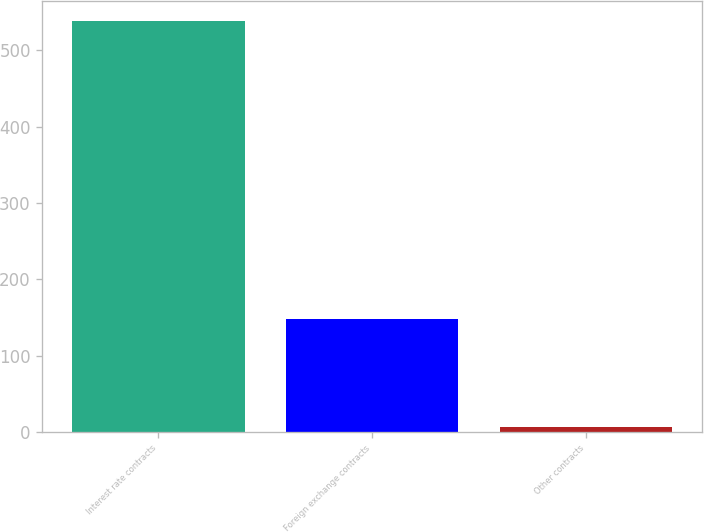<chart> <loc_0><loc_0><loc_500><loc_500><bar_chart><fcel>Interest rate contracts<fcel>Foreign exchange contracts<fcel>Other contracts<nl><fcel>538<fcel>148<fcel>7<nl></chart> 